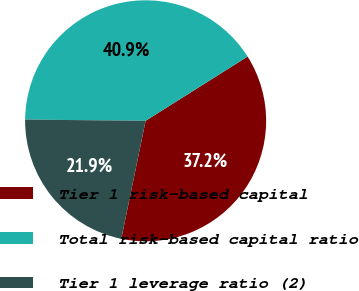Convert chart to OTSL. <chart><loc_0><loc_0><loc_500><loc_500><pie_chart><fcel>Tier 1 risk-based capital<fcel>Total risk-based capital ratio<fcel>Tier 1 leverage ratio (2)<nl><fcel>37.18%<fcel>40.89%<fcel>21.92%<nl></chart> 